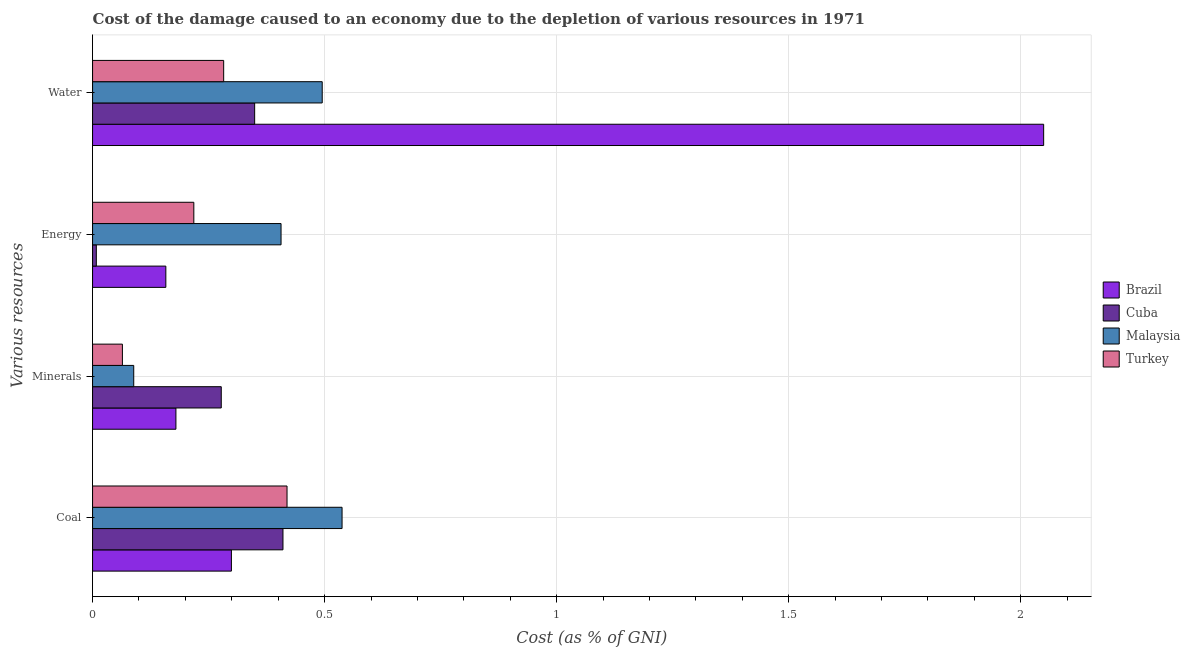How many different coloured bars are there?
Your answer should be compact. 4. Are the number of bars per tick equal to the number of legend labels?
Your answer should be very brief. Yes. Are the number of bars on each tick of the Y-axis equal?
Your answer should be compact. Yes. How many bars are there on the 2nd tick from the bottom?
Provide a short and direct response. 4. What is the label of the 3rd group of bars from the top?
Offer a terse response. Minerals. What is the cost of damage due to depletion of energy in Cuba?
Offer a terse response. 0.01. Across all countries, what is the maximum cost of damage due to depletion of coal?
Ensure brevity in your answer.  0.54. Across all countries, what is the minimum cost of damage due to depletion of water?
Your answer should be very brief. 0.28. In which country was the cost of damage due to depletion of energy maximum?
Provide a short and direct response. Malaysia. In which country was the cost of damage due to depletion of energy minimum?
Provide a short and direct response. Cuba. What is the total cost of damage due to depletion of coal in the graph?
Your answer should be compact. 1.67. What is the difference between the cost of damage due to depletion of water in Cuba and that in Brazil?
Provide a succinct answer. -1.7. What is the difference between the cost of damage due to depletion of minerals in Cuba and the cost of damage due to depletion of coal in Malaysia?
Ensure brevity in your answer.  -0.26. What is the average cost of damage due to depletion of coal per country?
Make the answer very short. 0.42. What is the difference between the cost of damage due to depletion of energy and cost of damage due to depletion of minerals in Turkey?
Provide a succinct answer. 0.15. In how many countries, is the cost of damage due to depletion of water greater than 1.7 %?
Keep it short and to the point. 1. What is the ratio of the cost of damage due to depletion of minerals in Cuba to that in Malaysia?
Offer a very short reply. 3.13. Is the cost of damage due to depletion of minerals in Turkey less than that in Brazil?
Your answer should be very brief. Yes. Is the difference between the cost of damage due to depletion of energy in Cuba and Turkey greater than the difference between the cost of damage due to depletion of water in Cuba and Turkey?
Keep it short and to the point. No. What is the difference between the highest and the second highest cost of damage due to depletion of minerals?
Give a very brief answer. 0.1. What is the difference between the highest and the lowest cost of damage due to depletion of minerals?
Ensure brevity in your answer.  0.21. In how many countries, is the cost of damage due to depletion of energy greater than the average cost of damage due to depletion of energy taken over all countries?
Keep it short and to the point. 2. Is it the case that in every country, the sum of the cost of damage due to depletion of water and cost of damage due to depletion of energy is greater than the sum of cost of damage due to depletion of coal and cost of damage due to depletion of minerals?
Offer a terse response. No. What does the 3rd bar from the top in Energy represents?
Ensure brevity in your answer.  Cuba. What does the 2nd bar from the bottom in Coal represents?
Keep it short and to the point. Cuba. How many countries are there in the graph?
Offer a very short reply. 4. What is the difference between two consecutive major ticks on the X-axis?
Ensure brevity in your answer.  0.5. Are the values on the major ticks of X-axis written in scientific E-notation?
Your response must be concise. No. Does the graph contain any zero values?
Make the answer very short. No. Does the graph contain grids?
Your answer should be compact. Yes. How many legend labels are there?
Offer a very short reply. 4. What is the title of the graph?
Provide a succinct answer. Cost of the damage caused to an economy due to the depletion of various resources in 1971 . Does "Germany" appear as one of the legend labels in the graph?
Keep it short and to the point. No. What is the label or title of the X-axis?
Offer a terse response. Cost (as % of GNI). What is the label or title of the Y-axis?
Ensure brevity in your answer.  Various resources. What is the Cost (as % of GNI) in Brazil in Coal?
Provide a succinct answer. 0.3. What is the Cost (as % of GNI) of Cuba in Coal?
Your response must be concise. 0.41. What is the Cost (as % of GNI) of Malaysia in Coal?
Your answer should be very brief. 0.54. What is the Cost (as % of GNI) of Turkey in Coal?
Your response must be concise. 0.42. What is the Cost (as % of GNI) in Brazil in Minerals?
Your response must be concise. 0.18. What is the Cost (as % of GNI) in Cuba in Minerals?
Offer a very short reply. 0.28. What is the Cost (as % of GNI) of Malaysia in Minerals?
Your answer should be very brief. 0.09. What is the Cost (as % of GNI) in Turkey in Minerals?
Offer a terse response. 0.06. What is the Cost (as % of GNI) of Brazil in Energy?
Provide a short and direct response. 0.16. What is the Cost (as % of GNI) of Cuba in Energy?
Offer a terse response. 0.01. What is the Cost (as % of GNI) in Malaysia in Energy?
Keep it short and to the point. 0.41. What is the Cost (as % of GNI) of Turkey in Energy?
Make the answer very short. 0.22. What is the Cost (as % of GNI) in Brazil in Water?
Make the answer very short. 2.05. What is the Cost (as % of GNI) in Cuba in Water?
Your answer should be very brief. 0.35. What is the Cost (as % of GNI) in Malaysia in Water?
Offer a very short reply. 0.49. What is the Cost (as % of GNI) of Turkey in Water?
Your answer should be compact. 0.28. Across all Various resources, what is the maximum Cost (as % of GNI) in Brazil?
Your answer should be very brief. 2.05. Across all Various resources, what is the maximum Cost (as % of GNI) of Cuba?
Give a very brief answer. 0.41. Across all Various resources, what is the maximum Cost (as % of GNI) in Malaysia?
Your response must be concise. 0.54. Across all Various resources, what is the maximum Cost (as % of GNI) of Turkey?
Offer a terse response. 0.42. Across all Various resources, what is the minimum Cost (as % of GNI) in Brazil?
Provide a short and direct response. 0.16. Across all Various resources, what is the minimum Cost (as % of GNI) of Cuba?
Provide a short and direct response. 0.01. Across all Various resources, what is the minimum Cost (as % of GNI) in Malaysia?
Your answer should be compact. 0.09. Across all Various resources, what is the minimum Cost (as % of GNI) in Turkey?
Your answer should be compact. 0.06. What is the total Cost (as % of GNI) of Brazil in the graph?
Offer a terse response. 2.69. What is the total Cost (as % of GNI) of Cuba in the graph?
Your answer should be very brief. 1.04. What is the total Cost (as % of GNI) of Malaysia in the graph?
Keep it short and to the point. 1.53. What is the difference between the Cost (as % of GNI) of Brazil in Coal and that in Minerals?
Your answer should be very brief. 0.12. What is the difference between the Cost (as % of GNI) of Cuba in Coal and that in Minerals?
Provide a succinct answer. 0.13. What is the difference between the Cost (as % of GNI) of Malaysia in Coal and that in Minerals?
Give a very brief answer. 0.45. What is the difference between the Cost (as % of GNI) in Turkey in Coal and that in Minerals?
Keep it short and to the point. 0.35. What is the difference between the Cost (as % of GNI) of Brazil in Coal and that in Energy?
Your response must be concise. 0.14. What is the difference between the Cost (as % of GNI) of Cuba in Coal and that in Energy?
Give a very brief answer. 0.4. What is the difference between the Cost (as % of GNI) of Malaysia in Coal and that in Energy?
Offer a very short reply. 0.13. What is the difference between the Cost (as % of GNI) in Turkey in Coal and that in Energy?
Ensure brevity in your answer.  0.2. What is the difference between the Cost (as % of GNI) of Brazil in Coal and that in Water?
Make the answer very short. -1.75. What is the difference between the Cost (as % of GNI) in Cuba in Coal and that in Water?
Offer a very short reply. 0.06. What is the difference between the Cost (as % of GNI) in Malaysia in Coal and that in Water?
Your answer should be very brief. 0.04. What is the difference between the Cost (as % of GNI) in Turkey in Coal and that in Water?
Your answer should be very brief. 0.14. What is the difference between the Cost (as % of GNI) in Brazil in Minerals and that in Energy?
Offer a terse response. 0.02. What is the difference between the Cost (as % of GNI) in Cuba in Minerals and that in Energy?
Give a very brief answer. 0.27. What is the difference between the Cost (as % of GNI) in Malaysia in Minerals and that in Energy?
Make the answer very short. -0.32. What is the difference between the Cost (as % of GNI) of Turkey in Minerals and that in Energy?
Give a very brief answer. -0.15. What is the difference between the Cost (as % of GNI) in Brazil in Minerals and that in Water?
Make the answer very short. -1.87. What is the difference between the Cost (as % of GNI) in Cuba in Minerals and that in Water?
Ensure brevity in your answer.  -0.07. What is the difference between the Cost (as % of GNI) in Malaysia in Minerals and that in Water?
Give a very brief answer. -0.41. What is the difference between the Cost (as % of GNI) in Turkey in Minerals and that in Water?
Keep it short and to the point. -0.22. What is the difference between the Cost (as % of GNI) in Brazil in Energy and that in Water?
Ensure brevity in your answer.  -1.89. What is the difference between the Cost (as % of GNI) of Cuba in Energy and that in Water?
Make the answer very short. -0.34. What is the difference between the Cost (as % of GNI) of Malaysia in Energy and that in Water?
Provide a succinct answer. -0.09. What is the difference between the Cost (as % of GNI) in Turkey in Energy and that in Water?
Provide a short and direct response. -0.06. What is the difference between the Cost (as % of GNI) in Brazil in Coal and the Cost (as % of GNI) in Cuba in Minerals?
Offer a very short reply. 0.02. What is the difference between the Cost (as % of GNI) in Brazil in Coal and the Cost (as % of GNI) in Malaysia in Minerals?
Provide a short and direct response. 0.21. What is the difference between the Cost (as % of GNI) of Brazil in Coal and the Cost (as % of GNI) of Turkey in Minerals?
Provide a succinct answer. 0.23. What is the difference between the Cost (as % of GNI) in Cuba in Coal and the Cost (as % of GNI) in Malaysia in Minerals?
Make the answer very short. 0.32. What is the difference between the Cost (as % of GNI) in Cuba in Coal and the Cost (as % of GNI) in Turkey in Minerals?
Provide a short and direct response. 0.35. What is the difference between the Cost (as % of GNI) in Malaysia in Coal and the Cost (as % of GNI) in Turkey in Minerals?
Your response must be concise. 0.47. What is the difference between the Cost (as % of GNI) in Brazil in Coal and the Cost (as % of GNI) in Cuba in Energy?
Ensure brevity in your answer.  0.29. What is the difference between the Cost (as % of GNI) in Brazil in Coal and the Cost (as % of GNI) in Malaysia in Energy?
Offer a terse response. -0.11. What is the difference between the Cost (as % of GNI) in Brazil in Coal and the Cost (as % of GNI) in Turkey in Energy?
Give a very brief answer. 0.08. What is the difference between the Cost (as % of GNI) in Cuba in Coal and the Cost (as % of GNI) in Malaysia in Energy?
Provide a succinct answer. 0. What is the difference between the Cost (as % of GNI) in Cuba in Coal and the Cost (as % of GNI) in Turkey in Energy?
Offer a terse response. 0.19. What is the difference between the Cost (as % of GNI) of Malaysia in Coal and the Cost (as % of GNI) of Turkey in Energy?
Offer a terse response. 0.32. What is the difference between the Cost (as % of GNI) of Brazil in Coal and the Cost (as % of GNI) of Cuba in Water?
Give a very brief answer. -0.05. What is the difference between the Cost (as % of GNI) of Brazil in Coal and the Cost (as % of GNI) of Malaysia in Water?
Make the answer very short. -0.2. What is the difference between the Cost (as % of GNI) in Brazil in Coal and the Cost (as % of GNI) in Turkey in Water?
Offer a very short reply. 0.02. What is the difference between the Cost (as % of GNI) in Cuba in Coal and the Cost (as % of GNI) in Malaysia in Water?
Keep it short and to the point. -0.08. What is the difference between the Cost (as % of GNI) in Cuba in Coal and the Cost (as % of GNI) in Turkey in Water?
Ensure brevity in your answer.  0.13. What is the difference between the Cost (as % of GNI) of Malaysia in Coal and the Cost (as % of GNI) of Turkey in Water?
Offer a terse response. 0.26. What is the difference between the Cost (as % of GNI) in Brazil in Minerals and the Cost (as % of GNI) in Cuba in Energy?
Provide a short and direct response. 0.17. What is the difference between the Cost (as % of GNI) of Brazil in Minerals and the Cost (as % of GNI) of Malaysia in Energy?
Your answer should be very brief. -0.23. What is the difference between the Cost (as % of GNI) in Brazil in Minerals and the Cost (as % of GNI) in Turkey in Energy?
Provide a succinct answer. -0.04. What is the difference between the Cost (as % of GNI) of Cuba in Minerals and the Cost (as % of GNI) of Malaysia in Energy?
Provide a short and direct response. -0.13. What is the difference between the Cost (as % of GNI) in Cuba in Minerals and the Cost (as % of GNI) in Turkey in Energy?
Your response must be concise. 0.06. What is the difference between the Cost (as % of GNI) in Malaysia in Minerals and the Cost (as % of GNI) in Turkey in Energy?
Your response must be concise. -0.13. What is the difference between the Cost (as % of GNI) in Brazil in Minerals and the Cost (as % of GNI) in Cuba in Water?
Provide a succinct answer. -0.17. What is the difference between the Cost (as % of GNI) in Brazil in Minerals and the Cost (as % of GNI) in Malaysia in Water?
Give a very brief answer. -0.32. What is the difference between the Cost (as % of GNI) of Brazil in Minerals and the Cost (as % of GNI) of Turkey in Water?
Offer a terse response. -0.1. What is the difference between the Cost (as % of GNI) in Cuba in Minerals and the Cost (as % of GNI) in Malaysia in Water?
Offer a very short reply. -0.22. What is the difference between the Cost (as % of GNI) in Cuba in Minerals and the Cost (as % of GNI) in Turkey in Water?
Provide a short and direct response. -0.01. What is the difference between the Cost (as % of GNI) of Malaysia in Minerals and the Cost (as % of GNI) of Turkey in Water?
Your answer should be very brief. -0.19. What is the difference between the Cost (as % of GNI) of Brazil in Energy and the Cost (as % of GNI) of Cuba in Water?
Ensure brevity in your answer.  -0.19. What is the difference between the Cost (as % of GNI) in Brazil in Energy and the Cost (as % of GNI) in Malaysia in Water?
Provide a succinct answer. -0.34. What is the difference between the Cost (as % of GNI) in Brazil in Energy and the Cost (as % of GNI) in Turkey in Water?
Offer a terse response. -0.12. What is the difference between the Cost (as % of GNI) in Cuba in Energy and the Cost (as % of GNI) in Malaysia in Water?
Offer a very short reply. -0.49. What is the difference between the Cost (as % of GNI) of Cuba in Energy and the Cost (as % of GNI) of Turkey in Water?
Offer a very short reply. -0.27. What is the difference between the Cost (as % of GNI) in Malaysia in Energy and the Cost (as % of GNI) in Turkey in Water?
Offer a terse response. 0.12. What is the average Cost (as % of GNI) of Brazil per Various resources?
Offer a terse response. 0.67. What is the average Cost (as % of GNI) in Cuba per Various resources?
Make the answer very short. 0.26. What is the average Cost (as % of GNI) in Malaysia per Various resources?
Keep it short and to the point. 0.38. What is the average Cost (as % of GNI) in Turkey per Various resources?
Give a very brief answer. 0.25. What is the difference between the Cost (as % of GNI) of Brazil and Cost (as % of GNI) of Cuba in Coal?
Provide a short and direct response. -0.11. What is the difference between the Cost (as % of GNI) in Brazil and Cost (as % of GNI) in Malaysia in Coal?
Make the answer very short. -0.24. What is the difference between the Cost (as % of GNI) in Brazil and Cost (as % of GNI) in Turkey in Coal?
Keep it short and to the point. -0.12. What is the difference between the Cost (as % of GNI) of Cuba and Cost (as % of GNI) of Malaysia in Coal?
Your answer should be compact. -0.13. What is the difference between the Cost (as % of GNI) of Cuba and Cost (as % of GNI) of Turkey in Coal?
Ensure brevity in your answer.  -0.01. What is the difference between the Cost (as % of GNI) in Malaysia and Cost (as % of GNI) in Turkey in Coal?
Offer a very short reply. 0.12. What is the difference between the Cost (as % of GNI) in Brazil and Cost (as % of GNI) in Cuba in Minerals?
Give a very brief answer. -0.1. What is the difference between the Cost (as % of GNI) of Brazil and Cost (as % of GNI) of Malaysia in Minerals?
Offer a very short reply. 0.09. What is the difference between the Cost (as % of GNI) of Brazil and Cost (as % of GNI) of Turkey in Minerals?
Make the answer very short. 0.12. What is the difference between the Cost (as % of GNI) in Cuba and Cost (as % of GNI) in Malaysia in Minerals?
Your answer should be very brief. 0.19. What is the difference between the Cost (as % of GNI) of Cuba and Cost (as % of GNI) of Turkey in Minerals?
Make the answer very short. 0.21. What is the difference between the Cost (as % of GNI) of Malaysia and Cost (as % of GNI) of Turkey in Minerals?
Keep it short and to the point. 0.02. What is the difference between the Cost (as % of GNI) of Brazil and Cost (as % of GNI) of Cuba in Energy?
Offer a terse response. 0.15. What is the difference between the Cost (as % of GNI) in Brazil and Cost (as % of GNI) in Malaysia in Energy?
Make the answer very short. -0.25. What is the difference between the Cost (as % of GNI) of Brazil and Cost (as % of GNI) of Turkey in Energy?
Your response must be concise. -0.06. What is the difference between the Cost (as % of GNI) of Cuba and Cost (as % of GNI) of Malaysia in Energy?
Keep it short and to the point. -0.4. What is the difference between the Cost (as % of GNI) in Cuba and Cost (as % of GNI) in Turkey in Energy?
Offer a terse response. -0.21. What is the difference between the Cost (as % of GNI) of Malaysia and Cost (as % of GNI) of Turkey in Energy?
Your response must be concise. 0.19. What is the difference between the Cost (as % of GNI) in Brazil and Cost (as % of GNI) in Cuba in Water?
Give a very brief answer. 1.7. What is the difference between the Cost (as % of GNI) in Brazil and Cost (as % of GNI) in Malaysia in Water?
Offer a terse response. 1.55. What is the difference between the Cost (as % of GNI) in Brazil and Cost (as % of GNI) in Turkey in Water?
Make the answer very short. 1.77. What is the difference between the Cost (as % of GNI) in Cuba and Cost (as % of GNI) in Malaysia in Water?
Give a very brief answer. -0.15. What is the difference between the Cost (as % of GNI) of Cuba and Cost (as % of GNI) of Turkey in Water?
Offer a very short reply. 0.07. What is the difference between the Cost (as % of GNI) in Malaysia and Cost (as % of GNI) in Turkey in Water?
Offer a very short reply. 0.21. What is the ratio of the Cost (as % of GNI) of Brazil in Coal to that in Minerals?
Provide a short and direct response. 1.67. What is the ratio of the Cost (as % of GNI) in Cuba in Coal to that in Minerals?
Offer a terse response. 1.48. What is the ratio of the Cost (as % of GNI) in Malaysia in Coal to that in Minerals?
Provide a short and direct response. 6.06. What is the ratio of the Cost (as % of GNI) of Turkey in Coal to that in Minerals?
Provide a succinct answer. 6.52. What is the ratio of the Cost (as % of GNI) in Brazil in Coal to that in Energy?
Offer a terse response. 1.89. What is the ratio of the Cost (as % of GNI) of Cuba in Coal to that in Energy?
Your answer should be compact. 50.69. What is the ratio of the Cost (as % of GNI) of Malaysia in Coal to that in Energy?
Offer a very short reply. 1.32. What is the ratio of the Cost (as % of GNI) in Turkey in Coal to that in Energy?
Make the answer very short. 1.92. What is the ratio of the Cost (as % of GNI) of Brazil in Coal to that in Water?
Your response must be concise. 0.15. What is the ratio of the Cost (as % of GNI) in Cuba in Coal to that in Water?
Your answer should be very brief. 1.17. What is the ratio of the Cost (as % of GNI) of Malaysia in Coal to that in Water?
Provide a succinct answer. 1.09. What is the ratio of the Cost (as % of GNI) in Turkey in Coal to that in Water?
Your answer should be compact. 1.48. What is the ratio of the Cost (as % of GNI) of Brazil in Minerals to that in Energy?
Offer a very short reply. 1.14. What is the ratio of the Cost (as % of GNI) of Cuba in Minerals to that in Energy?
Your response must be concise. 34.26. What is the ratio of the Cost (as % of GNI) in Malaysia in Minerals to that in Energy?
Your answer should be very brief. 0.22. What is the ratio of the Cost (as % of GNI) in Turkey in Minerals to that in Energy?
Your response must be concise. 0.29. What is the ratio of the Cost (as % of GNI) in Brazil in Minerals to that in Water?
Provide a short and direct response. 0.09. What is the ratio of the Cost (as % of GNI) in Cuba in Minerals to that in Water?
Provide a short and direct response. 0.79. What is the ratio of the Cost (as % of GNI) in Malaysia in Minerals to that in Water?
Make the answer very short. 0.18. What is the ratio of the Cost (as % of GNI) of Turkey in Minerals to that in Water?
Make the answer very short. 0.23. What is the ratio of the Cost (as % of GNI) in Brazil in Energy to that in Water?
Offer a terse response. 0.08. What is the ratio of the Cost (as % of GNI) in Cuba in Energy to that in Water?
Keep it short and to the point. 0.02. What is the ratio of the Cost (as % of GNI) of Malaysia in Energy to that in Water?
Offer a very short reply. 0.82. What is the ratio of the Cost (as % of GNI) of Turkey in Energy to that in Water?
Offer a very short reply. 0.77. What is the difference between the highest and the second highest Cost (as % of GNI) of Brazil?
Offer a terse response. 1.75. What is the difference between the highest and the second highest Cost (as % of GNI) in Cuba?
Keep it short and to the point. 0.06. What is the difference between the highest and the second highest Cost (as % of GNI) in Malaysia?
Make the answer very short. 0.04. What is the difference between the highest and the second highest Cost (as % of GNI) in Turkey?
Keep it short and to the point. 0.14. What is the difference between the highest and the lowest Cost (as % of GNI) of Brazil?
Offer a terse response. 1.89. What is the difference between the highest and the lowest Cost (as % of GNI) in Cuba?
Ensure brevity in your answer.  0.4. What is the difference between the highest and the lowest Cost (as % of GNI) in Malaysia?
Ensure brevity in your answer.  0.45. What is the difference between the highest and the lowest Cost (as % of GNI) in Turkey?
Keep it short and to the point. 0.35. 